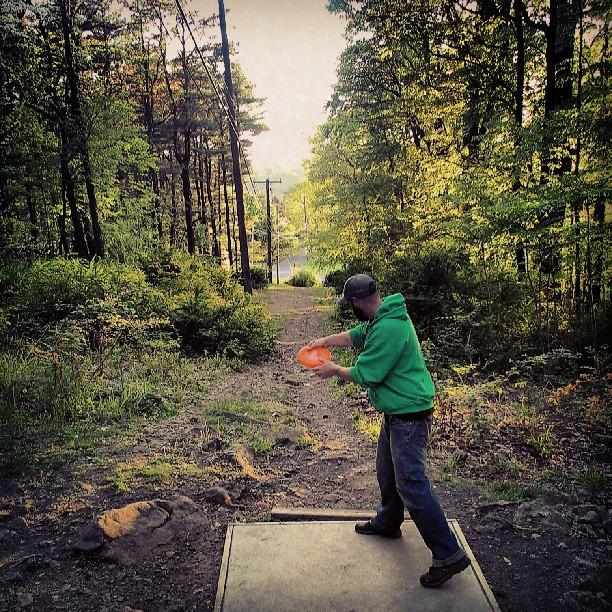The ground that the man is standing on is made of what material? Please explain your reasoning. cement. The surface is smooth, dull and grey. 